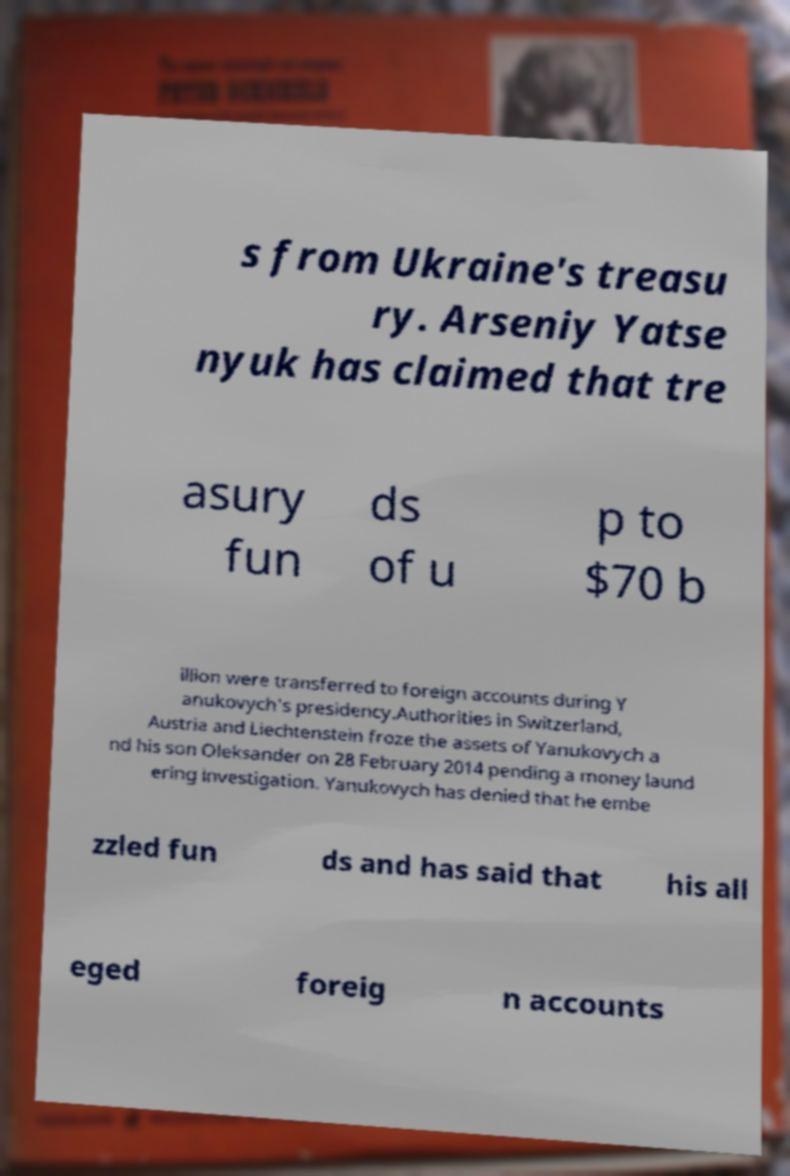Can you read and provide the text displayed in the image?This photo seems to have some interesting text. Can you extract and type it out for me? s from Ukraine's treasu ry. Arseniy Yatse nyuk has claimed that tre asury fun ds of u p to $70 b illion were transferred to foreign accounts during Y anukovych's presidency.Authorities in Switzerland, Austria and Liechtenstein froze the assets of Yanukovych a nd his son Oleksander on 28 February 2014 pending a money laund ering investigation. Yanukovych has denied that he embe zzled fun ds and has said that his all eged foreig n accounts 